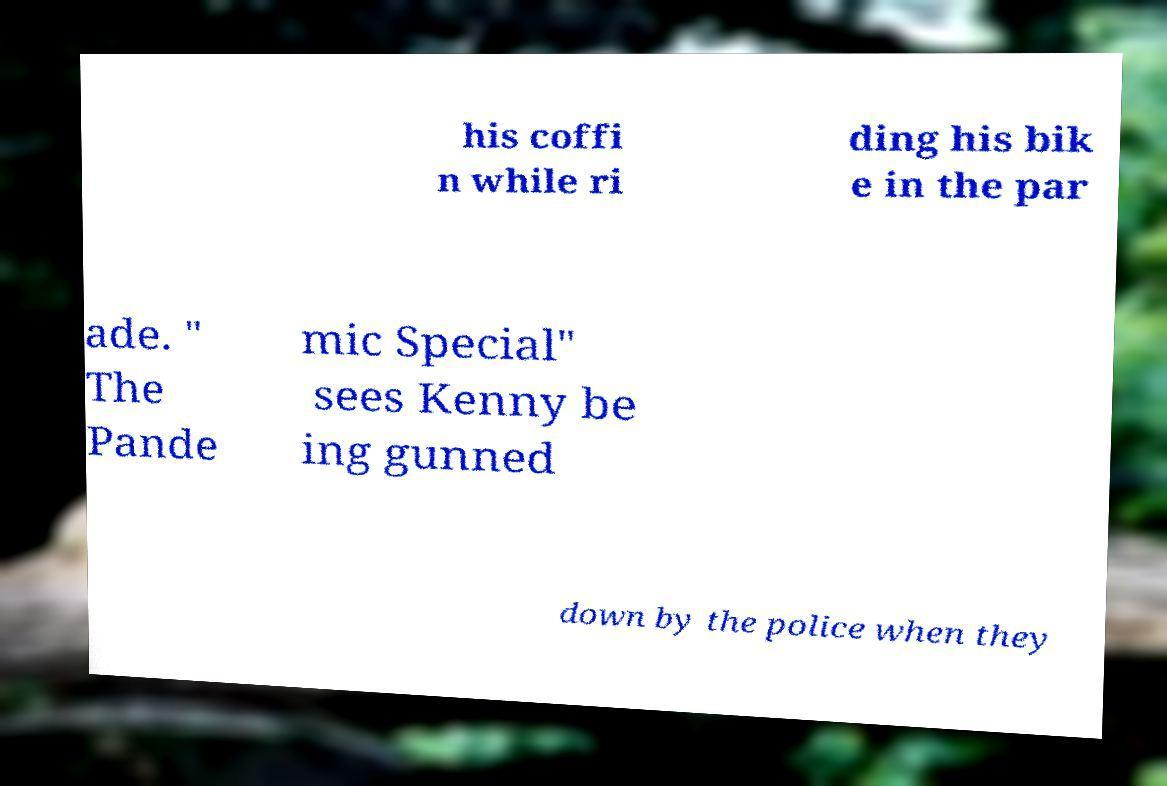Can you accurately transcribe the text from the provided image for me? his coffi n while ri ding his bik e in the par ade. " The Pande mic Special" sees Kenny be ing gunned down by the police when they 